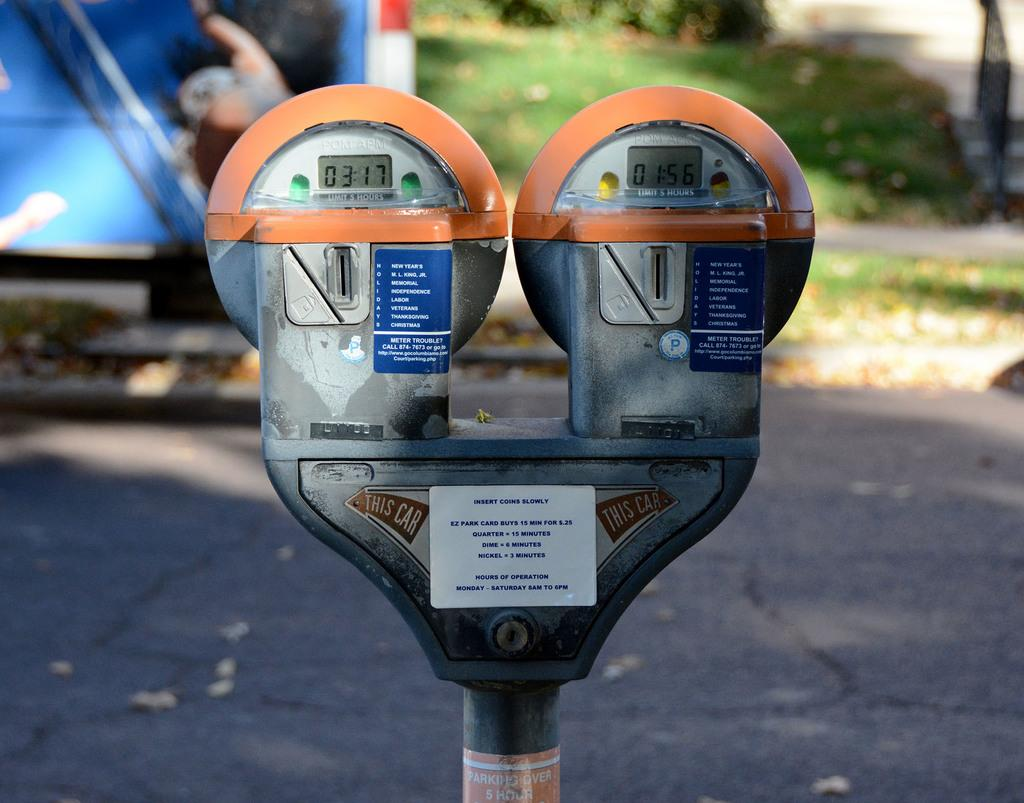What object is the main focus of the image? There is a parking meter in the image. What can be seen on the parking meter? The parking meter has labels attached to it. Where is the image likely taken? The image appears to be on a road. What else can be seen in the image? There is a vehicle visible in the background and grass is present in the image. What type of magic is being performed with the parking meter in the image? There is no magic being performed in the image; it simply shows a parking meter with labels attached to it. Can you see a ring on the parking meter in the image? There is no ring present on the parking meter in the image. 